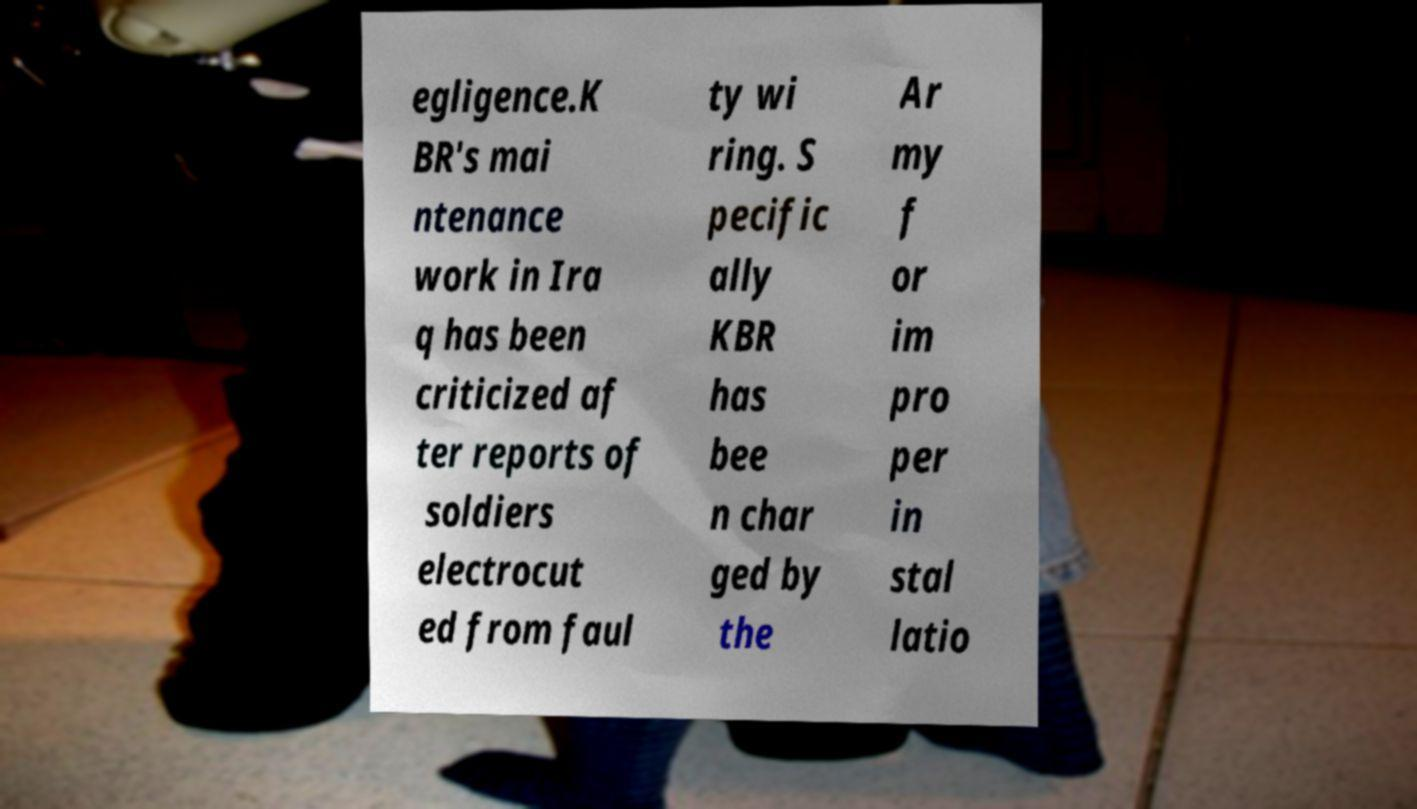Could you extract and type out the text from this image? egligence.K BR's mai ntenance work in Ira q has been criticized af ter reports of soldiers electrocut ed from faul ty wi ring. S pecific ally KBR has bee n char ged by the Ar my f or im pro per in stal latio 